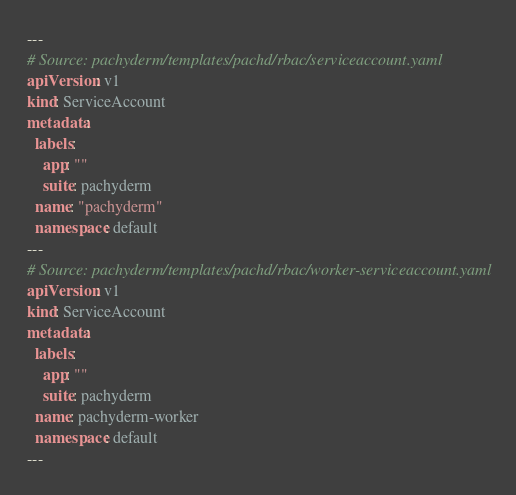<code> <loc_0><loc_0><loc_500><loc_500><_YAML_>---
# Source: pachyderm/templates/pachd/rbac/serviceaccount.yaml
apiVersion: v1
kind: ServiceAccount
metadata:
  labels:
    app: ""
    suite: pachyderm
  name: "pachyderm"
  namespace: default
---
# Source: pachyderm/templates/pachd/rbac/worker-serviceaccount.yaml
apiVersion: v1
kind: ServiceAccount
metadata:
  labels:
    app: ""
    suite: pachyderm
  name: pachyderm-worker
  namespace: default
---</code> 